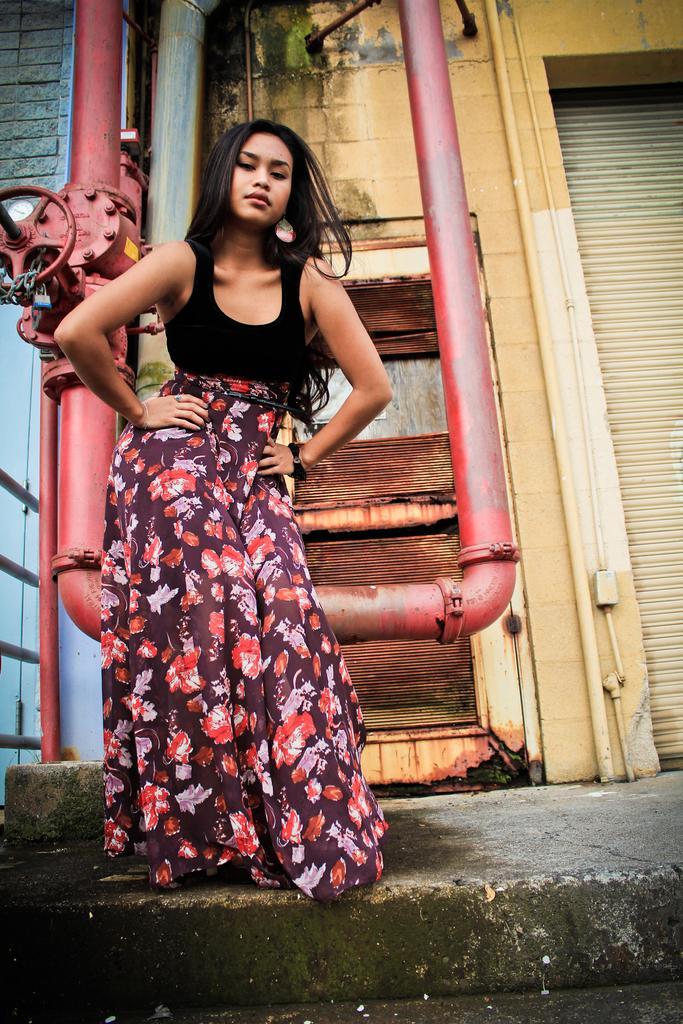Can you describe this image briefly? In this image I can see a woman on the road. In the background, I can see buildings, metal pipes and walls. This image is taken may be during a day. 